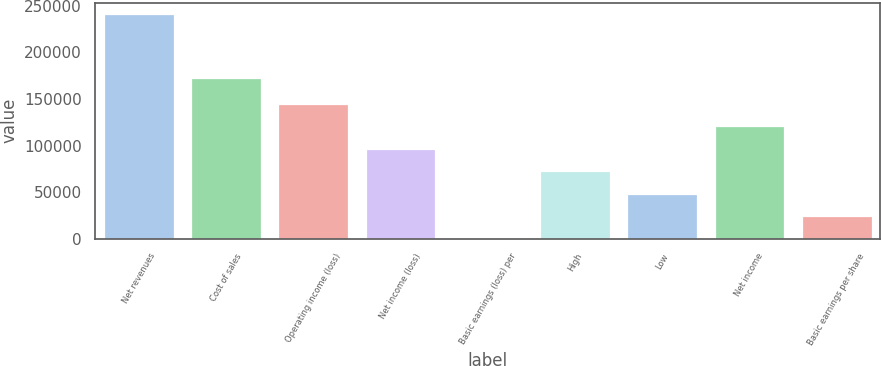<chart> <loc_0><loc_0><loc_500><loc_500><bar_chart><fcel>Net revenues<fcel>Cost of sales<fcel>Operating income (loss)<fcel>Net income (loss)<fcel>Basic earnings (loss) per<fcel>High<fcel>Low<fcel>Net income<fcel>Basic earnings per share<nl><fcel>241093<fcel>172270<fcel>144656<fcel>96437.2<fcel>0.01<fcel>72327.9<fcel>48218.6<fcel>120547<fcel>24109.3<nl></chart> 